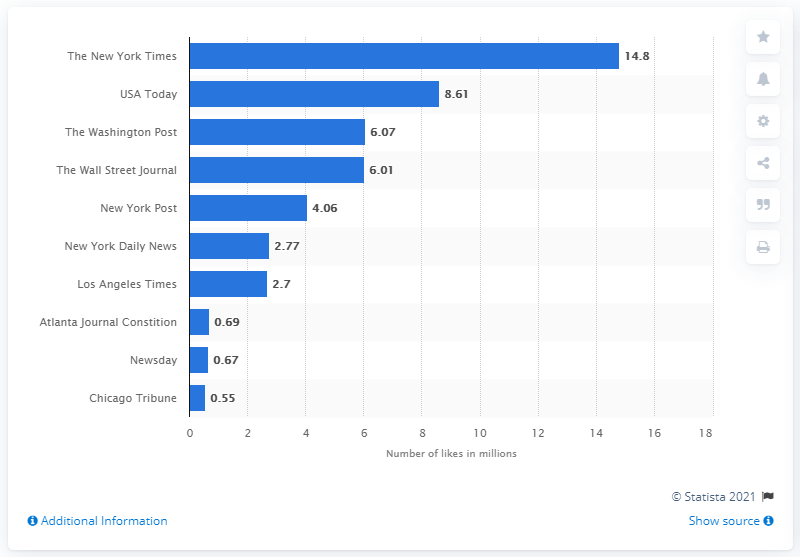Draw attention to some important aspects in this diagram. As of October 2017, The New York Times had received 14.8 likes. The number of likes received by USA Today is 8.61. 